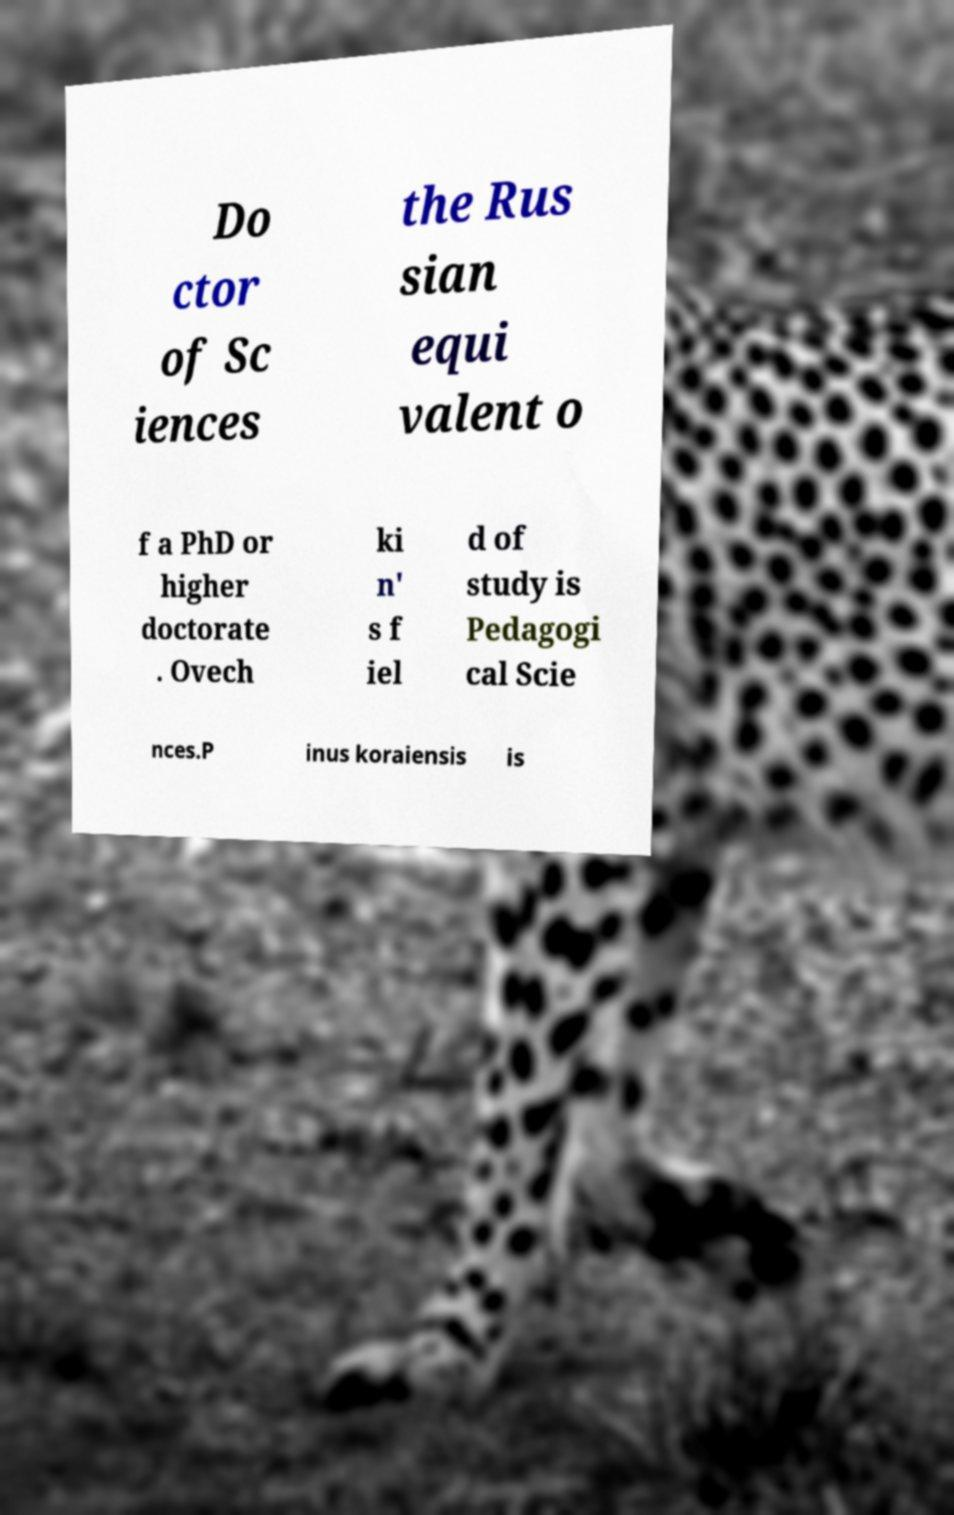Could you assist in decoding the text presented in this image and type it out clearly? Do ctor of Sc iences the Rus sian equi valent o f a PhD or higher doctorate . Ovech ki n' s f iel d of study is Pedagogi cal Scie nces.P inus koraiensis is 